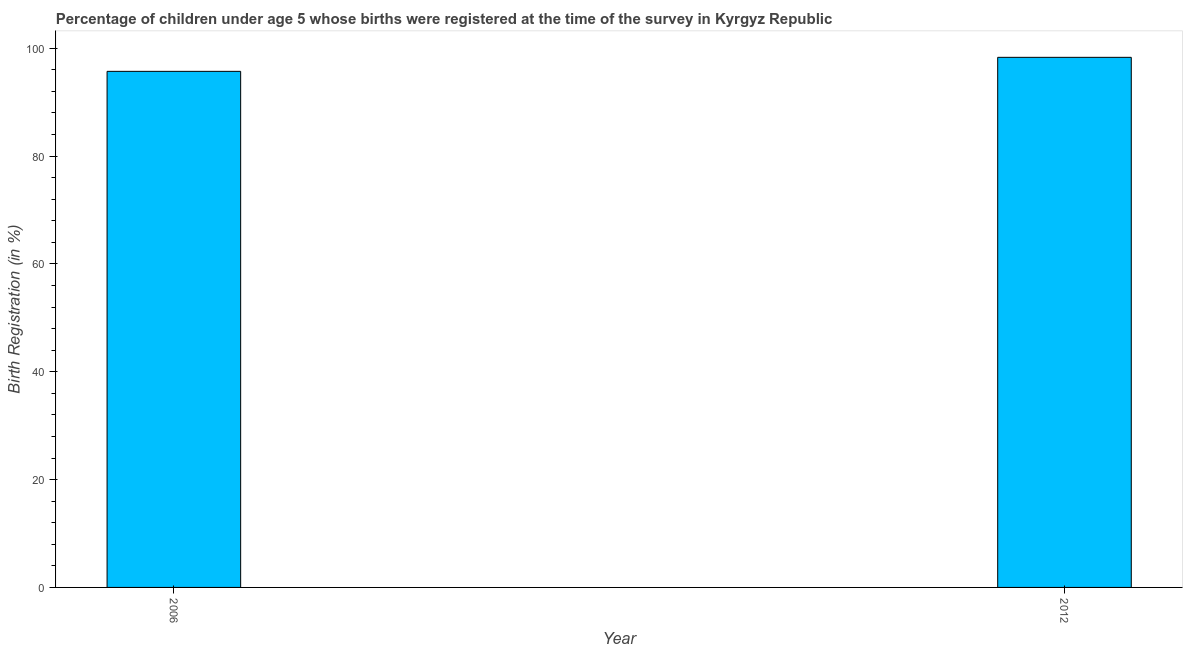Does the graph contain any zero values?
Give a very brief answer. No. What is the title of the graph?
Make the answer very short. Percentage of children under age 5 whose births were registered at the time of the survey in Kyrgyz Republic. What is the label or title of the Y-axis?
Your response must be concise. Birth Registration (in %). What is the birth registration in 2012?
Provide a short and direct response. 98.3. Across all years, what is the maximum birth registration?
Your answer should be compact. 98.3. Across all years, what is the minimum birth registration?
Your response must be concise. 95.7. In which year was the birth registration maximum?
Keep it short and to the point. 2012. In which year was the birth registration minimum?
Your answer should be very brief. 2006. What is the sum of the birth registration?
Your answer should be compact. 194. What is the average birth registration per year?
Your response must be concise. 97. What is the median birth registration?
Your answer should be very brief. 97. Do a majority of the years between 2006 and 2012 (inclusive) have birth registration greater than 84 %?
Offer a terse response. Yes. In how many years, is the birth registration greater than the average birth registration taken over all years?
Provide a succinct answer. 1. How many bars are there?
Your answer should be very brief. 2. Are all the bars in the graph horizontal?
Offer a terse response. No. How many years are there in the graph?
Provide a short and direct response. 2. What is the difference between two consecutive major ticks on the Y-axis?
Make the answer very short. 20. What is the Birth Registration (in %) in 2006?
Give a very brief answer. 95.7. What is the Birth Registration (in %) in 2012?
Ensure brevity in your answer.  98.3. What is the difference between the Birth Registration (in %) in 2006 and 2012?
Your response must be concise. -2.6. 